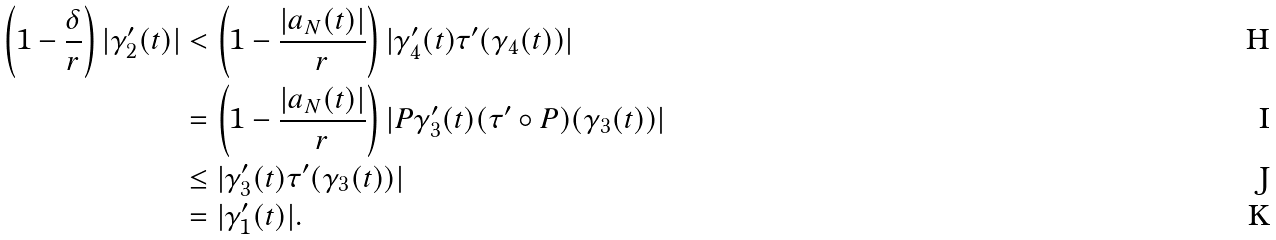Convert formula to latex. <formula><loc_0><loc_0><loc_500><loc_500>\left ( 1 - \frac { \delta } { r } \right ) | \gamma _ { 2 } ^ { \prime } ( t ) | & < \left ( 1 - \frac { | a _ { N } ( t ) | } { r } \right ) | \gamma _ { 4 } ^ { \prime } ( t ) \tau ^ { \prime } ( \gamma _ { 4 } ( t ) ) | \\ & = \left ( 1 - \frac { | a _ { N } ( t ) | } { r } \right ) | P \gamma _ { 3 } ^ { \prime } ( t ) ( \tau ^ { \prime } \circ P ) ( \gamma _ { 3 } ( t ) ) | \\ & \leq | \gamma _ { 3 } ^ { \prime } ( t ) \tau ^ { \prime } ( \gamma _ { 3 } ( t ) ) | \\ & = | \gamma _ { 1 } ^ { \prime } ( t ) | .</formula> 